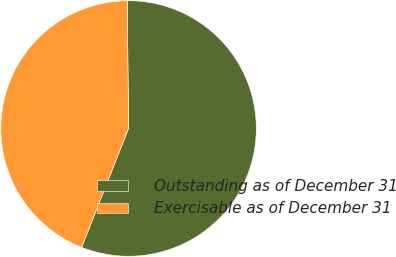<chart> <loc_0><loc_0><loc_500><loc_500><pie_chart><fcel>Outstanding as of December 31<fcel>Exercisable as of December 31<nl><fcel>56.14%<fcel>43.86%<nl></chart> 